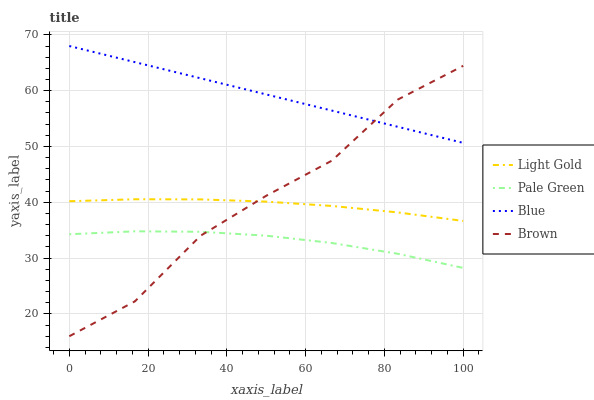Does Brown have the minimum area under the curve?
Answer yes or no. No. Does Brown have the maximum area under the curve?
Answer yes or no. No. Is Pale Green the smoothest?
Answer yes or no. No. Is Pale Green the roughest?
Answer yes or no. No. Does Pale Green have the lowest value?
Answer yes or no. No. Does Brown have the highest value?
Answer yes or no. No. Is Light Gold less than Blue?
Answer yes or no. Yes. Is Blue greater than Light Gold?
Answer yes or no. Yes. Does Light Gold intersect Blue?
Answer yes or no. No. 